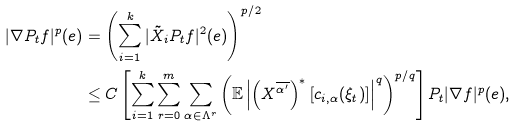<formula> <loc_0><loc_0><loc_500><loc_500>| \nabla P _ { t } f | ^ { p } ( e ) & = \left ( \sum _ { i = 1 } ^ { k } | \tilde { X } _ { i } P _ { t } f | ^ { 2 } ( e ) \right ) ^ { p / 2 } \\ & \leq C \left [ \sum _ { i = 1 } ^ { k } \sum _ { r = 0 } ^ { m } \sum _ { \alpha \in \Lambda ^ { r } } \left ( \mathbb { E } \left | \left ( X ^ { \overline { \alpha ^ { \prime } } } \right ) ^ { * } \left [ c _ { i , \alpha } ( \xi _ { t } ) \right ] \right | ^ { q } \right ) ^ { p / q } \right ] P _ { t } | \nabla f | ^ { p } ( e ) ,</formula> 